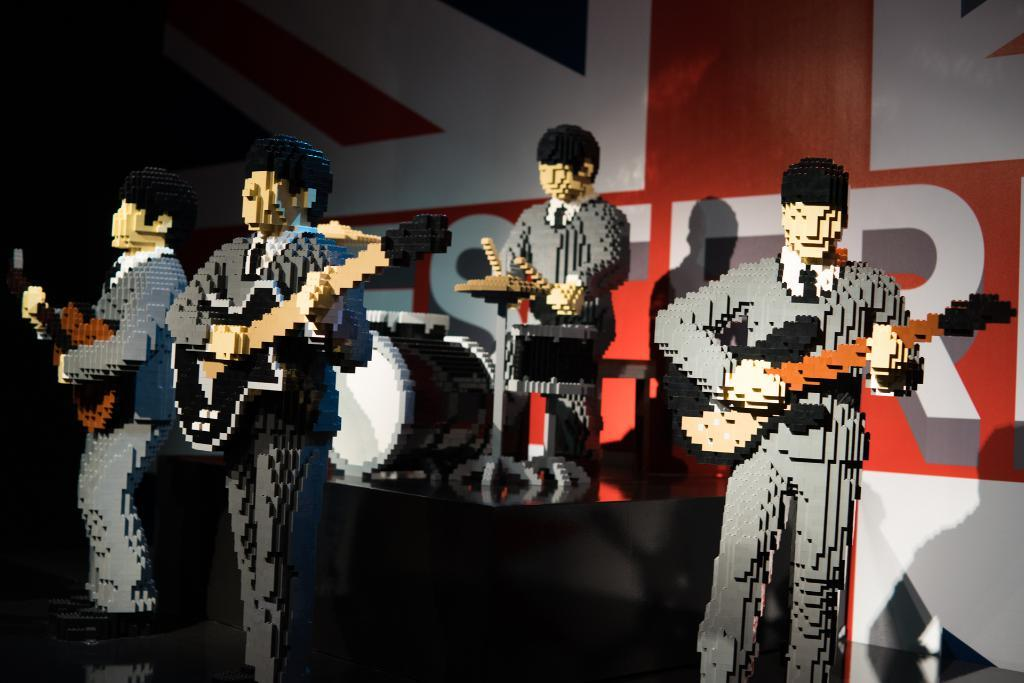What type of characters are depicted in the image? There are cartoons in the image. What are the cartoons doing in the image? Some cartoons are playing musical instruments, including guitars and drums. Can you identify any specific musical instruments being played by the cartoons? Yes, one cartoon is playing drums, and some cartoons are playing guitars. How many nerves can be seen in the image? There are no nerves visible in the image, as it features cartoons playing musical instruments. What type of lift is present in the image? There is no lift present in the image. 